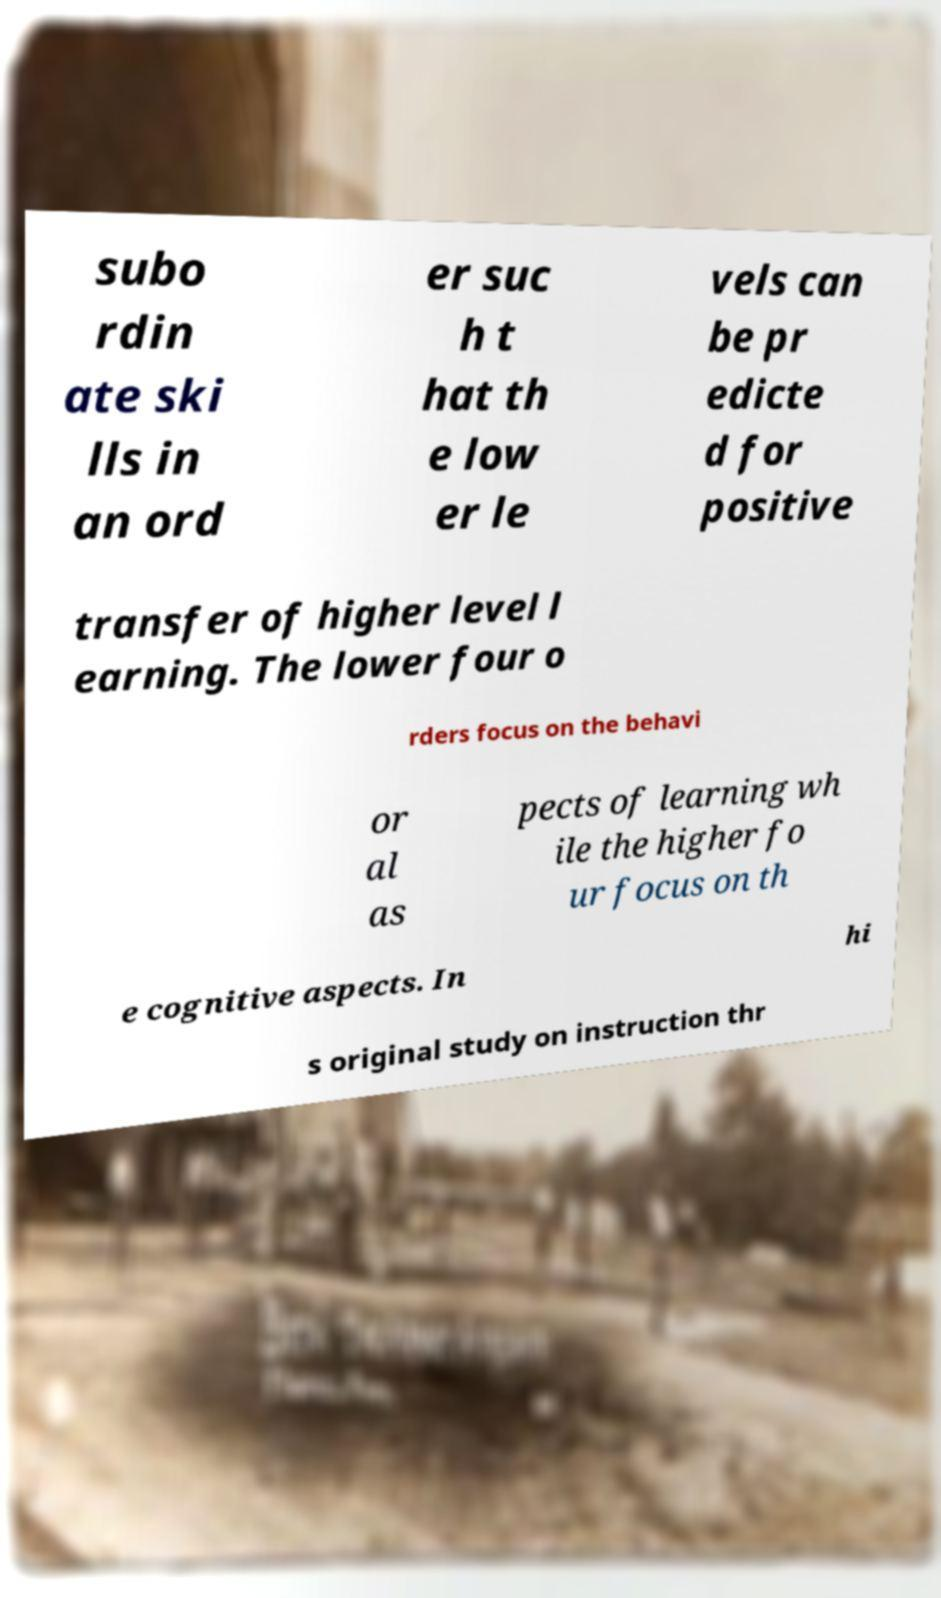Please read and relay the text visible in this image. What does it say? subo rdin ate ski lls in an ord er suc h t hat th e low er le vels can be pr edicte d for positive transfer of higher level l earning. The lower four o rders focus on the behavi or al as pects of learning wh ile the higher fo ur focus on th e cognitive aspects. In hi s original study on instruction thr 